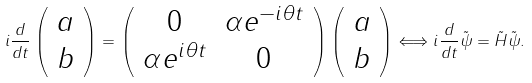<formula> <loc_0><loc_0><loc_500><loc_500>i \frac { d } { d t } \left ( \begin{array} { c } a \\ b \end{array} \right ) = \left ( \begin{array} { c c } 0 & \alpha e ^ { - i \theta t } \\ \alpha e ^ { i \theta t } & 0 \end{array} \right ) \left ( \begin{array} { c } a \\ b \end{array} \right ) \Longleftrightarrow i \frac { d } { d t } { \tilde { \psi } } = { \tilde { H } } { \tilde { \psi } } .</formula> 